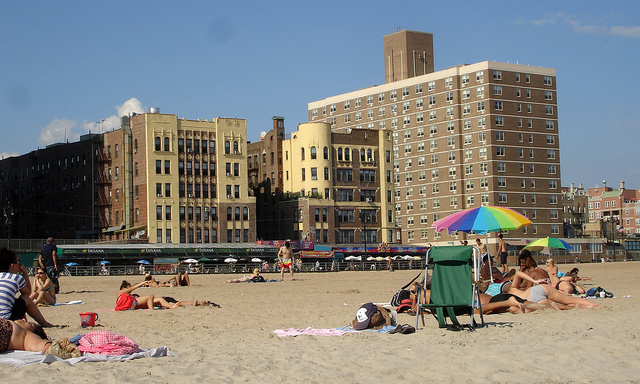Where is someone who might easily overheat safest here? A. on chair B. under umbrella C. in sand D. water's edge Option B, under the umbrella, is the safest place for someone who might easily overheat. The umbrella provides shade and can significantly reduce exposure to direct sunlight, thus helping to avoid overheating and sunburn. It offers a cool refuge, especially on a sunny beach day, where the heat can be intense. 